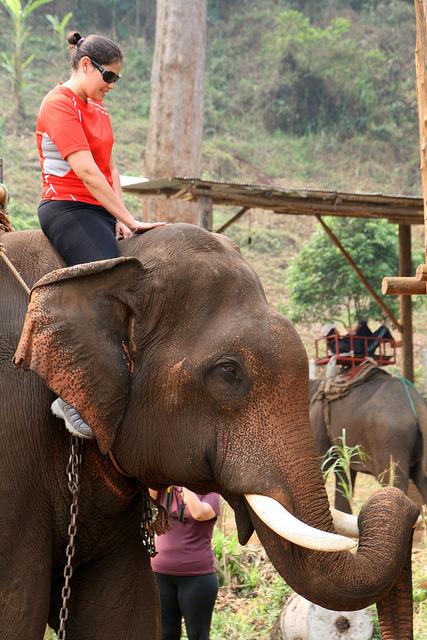Is this animal a mammal?
Concise answer only. Yes. What is the woman riding?
Answer briefly. Elephant. Does the elephant have tusks?
Write a very short answer. Yes. 